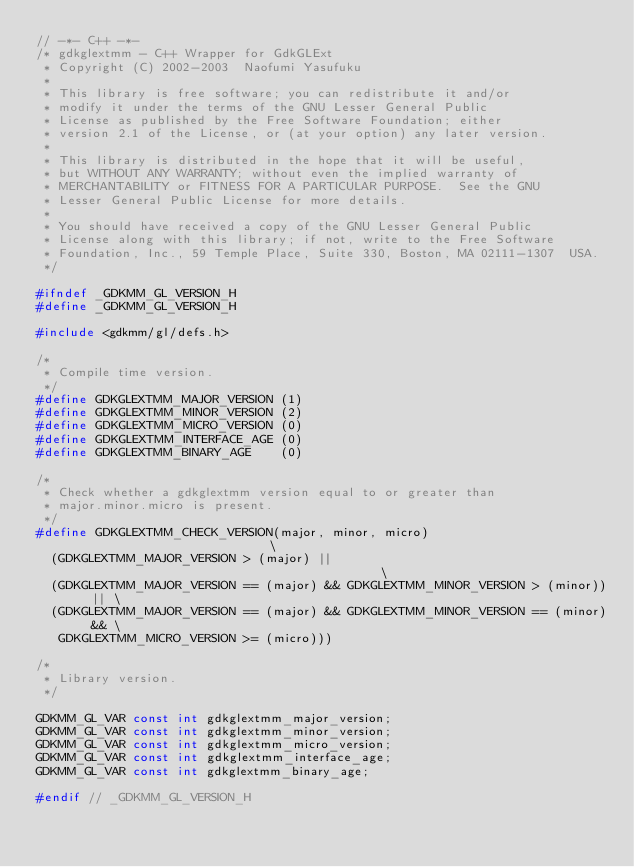Convert code to text. <code><loc_0><loc_0><loc_500><loc_500><_C_>// -*- C++ -*-
/* gdkglextmm - C++ Wrapper for GdkGLExt
 * Copyright (C) 2002-2003  Naofumi Yasufuku
 *
 * This library is free software; you can redistribute it and/or
 * modify it under the terms of the GNU Lesser General Public
 * License as published by the Free Software Foundation; either
 * version 2.1 of the License, or (at your option) any later version.
 *
 * This library is distributed in the hope that it will be useful,
 * but WITHOUT ANY WARRANTY; without even the implied warranty of
 * MERCHANTABILITY or FITNESS FOR A PARTICULAR PURPOSE.  See the GNU
 * Lesser General Public License for more details.
 *
 * You should have received a copy of the GNU Lesser General Public
 * License along with this library; if not, write to the Free Software
 * Foundation, Inc., 59 Temple Place, Suite 330, Boston, MA 02111-1307  USA.
 */

#ifndef _GDKMM_GL_VERSION_H
#define _GDKMM_GL_VERSION_H

#include <gdkmm/gl/defs.h>

/*
 * Compile time version.
 */
#define GDKGLEXTMM_MAJOR_VERSION (1)
#define GDKGLEXTMM_MINOR_VERSION (2)
#define GDKGLEXTMM_MICRO_VERSION (0)
#define GDKGLEXTMM_INTERFACE_AGE (0)
#define GDKGLEXTMM_BINARY_AGE    (0)

/*
 * Check whether a gdkglextmm version equal to or greater than
 * major.minor.micro is present.
 */
#define	GDKGLEXTMM_CHECK_VERSION(major, minor, micro)                            \
  (GDKGLEXTMM_MAJOR_VERSION > (major) ||                                         \
  (GDKGLEXTMM_MAJOR_VERSION == (major) && GDKGLEXTMM_MINOR_VERSION > (minor)) || \
  (GDKGLEXTMM_MAJOR_VERSION == (major) && GDKGLEXTMM_MINOR_VERSION == (minor) && \
   GDKGLEXTMM_MICRO_VERSION >= (micro)))

/*
 * Library version.
 */

GDKMM_GL_VAR const int gdkglextmm_major_version;
GDKMM_GL_VAR const int gdkglextmm_minor_version;
GDKMM_GL_VAR const int gdkglextmm_micro_version;
GDKMM_GL_VAR const int gdkglextmm_interface_age;
GDKMM_GL_VAR const int gdkglextmm_binary_age;

#endif // _GDKMM_GL_VERSION_H
</code> 